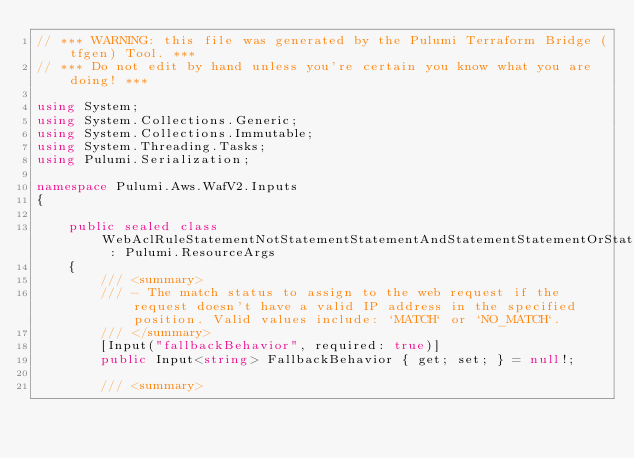<code> <loc_0><loc_0><loc_500><loc_500><_C#_>// *** WARNING: this file was generated by the Pulumi Terraform Bridge (tfgen) Tool. ***
// *** Do not edit by hand unless you're certain you know what you are doing! ***

using System;
using System.Collections.Generic;
using System.Collections.Immutable;
using System.Threading.Tasks;
using Pulumi.Serialization;

namespace Pulumi.Aws.WafV2.Inputs
{

    public sealed class WebAclRuleStatementNotStatementStatementAndStatementStatementOrStatementStatementGeoMatchStatementForwardedIpConfigGetArgs : Pulumi.ResourceArgs
    {
        /// <summary>
        /// - The match status to assign to the web request if the request doesn't have a valid IP address in the specified position. Valid values include: `MATCH` or `NO_MATCH`.
        /// </summary>
        [Input("fallbackBehavior", required: true)]
        public Input<string> FallbackBehavior { get; set; } = null!;

        /// <summary></code> 